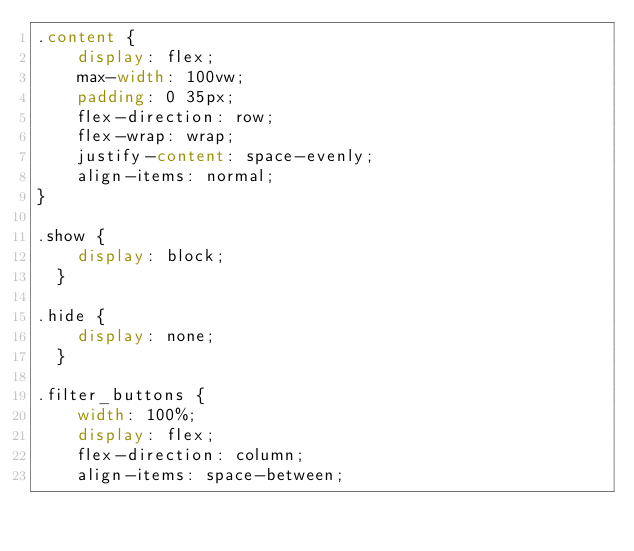<code> <loc_0><loc_0><loc_500><loc_500><_CSS_>.content {
    display: flex;
    max-width: 100vw;
    padding: 0 35px;
    flex-direction: row;
    flex-wrap: wrap;
    justify-content: space-evenly;
    align-items: normal;
}

.show {
    display: block;
  }
  
.hide {
    display: none;
  }

.filter_buttons {
    width: 100%;
    display: flex;
    flex-direction: column;
    align-items: space-between;</code> 